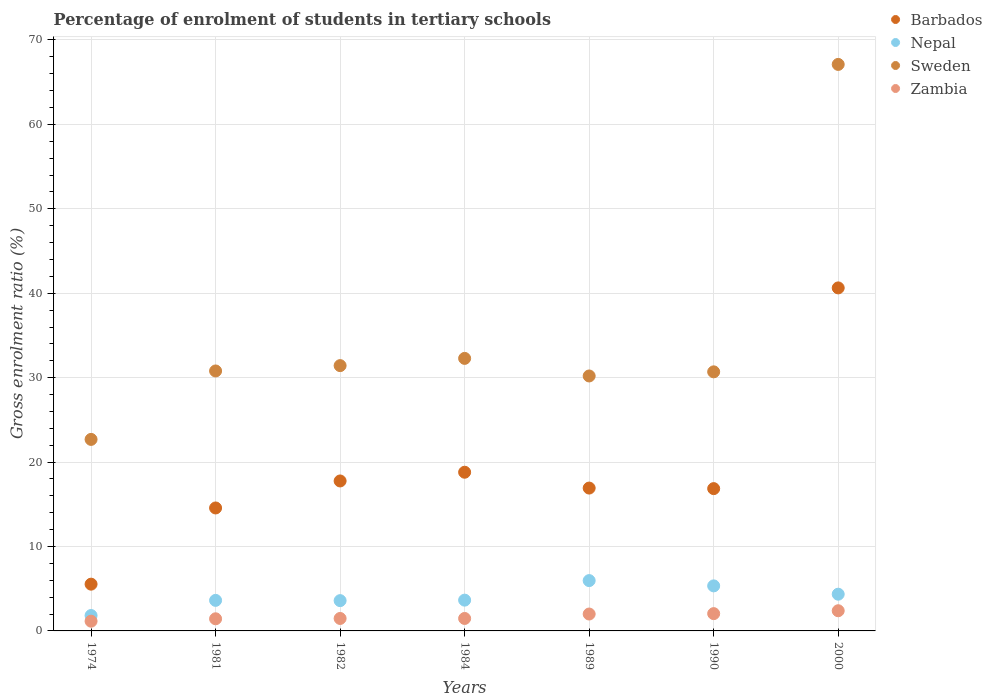What is the percentage of students enrolled in tertiary schools in Zambia in 2000?
Offer a terse response. 2.39. Across all years, what is the maximum percentage of students enrolled in tertiary schools in Barbados?
Offer a terse response. 40.63. Across all years, what is the minimum percentage of students enrolled in tertiary schools in Sweden?
Offer a very short reply. 22.69. In which year was the percentage of students enrolled in tertiary schools in Nepal minimum?
Give a very brief answer. 1974. What is the total percentage of students enrolled in tertiary schools in Barbados in the graph?
Offer a terse response. 131.07. What is the difference between the percentage of students enrolled in tertiary schools in Nepal in 1982 and that in 1990?
Offer a terse response. -1.75. What is the difference between the percentage of students enrolled in tertiary schools in Sweden in 1989 and the percentage of students enrolled in tertiary schools in Zambia in 2000?
Your answer should be very brief. 27.81. What is the average percentage of students enrolled in tertiary schools in Sweden per year?
Your answer should be very brief. 35.03. In the year 2000, what is the difference between the percentage of students enrolled in tertiary schools in Zambia and percentage of students enrolled in tertiary schools in Nepal?
Offer a terse response. -1.96. What is the ratio of the percentage of students enrolled in tertiary schools in Zambia in 1989 to that in 1990?
Your answer should be compact. 0.98. Is the percentage of students enrolled in tertiary schools in Nepal in 1981 less than that in 1989?
Your answer should be compact. Yes. Is the difference between the percentage of students enrolled in tertiary schools in Zambia in 1982 and 2000 greater than the difference between the percentage of students enrolled in tertiary schools in Nepal in 1982 and 2000?
Your response must be concise. No. What is the difference between the highest and the second highest percentage of students enrolled in tertiary schools in Sweden?
Provide a short and direct response. 34.82. What is the difference between the highest and the lowest percentage of students enrolled in tertiary schools in Nepal?
Keep it short and to the point. 4.14. Is the sum of the percentage of students enrolled in tertiary schools in Sweden in 1974 and 1982 greater than the maximum percentage of students enrolled in tertiary schools in Nepal across all years?
Provide a short and direct response. Yes. Is it the case that in every year, the sum of the percentage of students enrolled in tertiary schools in Zambia and percentage of students enrolled in tertiary schools in Sweden  is greater than the sum of percentage of students enrolled in tertiary schools in Nepal and percentage of students enrolled in tertiary schools in Barbados?
Your answer should be compact. Yes. Does the percentage of students enrolled in tertiary schools in Nepal monotonically increase over the years?
Your answer should be compact. No. How many dotlines are there?
Offer a terse response. 4. What is the difference between two consecutive major ticks on the Y-axis?
Your response must be concise. 10. Does the graph contain any zero values?
Ensure brevity in your answer.  No. Does the graph contain grids?
Offer a terse response. Yes. Where does the legend appear in the graph?
Your response must be concise. Top right. How many legend labels are there?
Make the answer very short. 4. What is the title of the graph?
Your answer should be compact. Percentage of enrolment of students in tertiary schools. Does "Lower middle income" appear as one of the legend labels in the graph?
Give a very brief answer. No. What is the label or title of the X-axis?
Your response must be concise. Years. What is the Gross enrolment ratio (%) of Barbados in 1974?
Provide a succinct answer. 5.54. What is the Gross enrolment ratio (%) of Nepal in 1974?
Your response must be concise. 1.82. What is the Gross enrolment ratio (%) in Sweden in 1974?
Offer a terse response. 22.69. What is the Gross enrolment ratio (%) of Zambia in 1974?
Your answer should be compact. 1.15. What is the Gross enrolment ratio (%) in Barbados in 1981?
Your answer should be very brief. 14.56. What is the Gross enrolment ratio (%) in Nepal in 1981?
Give a very brief answer. 3.62. What is the Gross enrolment ratio (%) in Sweden in 1981?
Your answer should be very brief. 30.79. What is the Gross enrolment ratio (%) of Zambia in 1981?
Offer a terse response. 1.44. What is the Gross enrolment ratio (%) in Barbados in 1982?
Your response must be concise. 17.76. What is the Gross enrolment ratio (%) of Nepal in 1982?
Keep it short and to the point. 3.59. What is the Gross enrolment ratio (%) in Sweden in 1982?
Your answer should be compact. 31.43. What is the Gross enrolment ratio (%) of Zambia in 1982?
Your answer should be very brief. 1.48. What is the Gross enrolment ratio (%) of Barbados in 1984?
Offer a terse response. 18.8. What is the Gross enrolment ratio (%) of Nepal in 1984?
Give a very brief answer. 3.65. What is the Gross enrolment ratio (%) in Sweden in 1984?
Your answer should be very brief. 32.28. What is the Gross enrolment ratio (%) in Zambia in 1984?
Provide a short and direct response. 1.48. What is the Gross enrolment ratio (%) of Barbados in 1989?
Provide a short and direct response. 16.92. What is the Gross enrolment ratio (%) in Nepal in 1989?
Provide a succinct answer. 5.96. What is the Gross enrolment ratio (%) in Sweden in 1989?
Provide a succinct answer. 30.2. What is the Gross enrolment ratio (%) in Zambia in 1989?
Make the answer very short. 2. What is the Gross enrolment ratio (%) in Barbados in 1990?
Your answer should be very brief. 16.86. What is the Gross enrolment ratio (%) in Nepal in 1990?
Ensure brevity in your answer.  5.34. What is the Gross enrolment ratio (%) of Sweden in 1990?
Offer a terse response. 30.69. What is the Gross enrolment ratio (%) in Zambia in 1990?
Offer a terse response. 2.05. What is the Gross enrolment ratio (%) of Barbados in 2000?
Keep it short and to the point. 40.63. What is the Gross enrolment ratio (%) in Nepal in 2000?
Give a very brief answer. 4.35. What is the Gross enrolment ratio (%) in Sweden in 2000?
Make the answer very short. 67.11. What is the Gross enrolment ratio (%) in Zambia in 2000?
Ensure brevity in your answer.  2.39. Across all years, what is the maximum Gross enrolment ratio (%) in Barbados?
Ensure brevity in your answer.  40.63. Across all years, what is the maximum Gross enrolment ratio (%) of Nepal?
Your answer should be compact. 5.96. Across all years, what is the maximum Gross enrolment ratio (%) in Sweden?
Offer a very short reply. 67.11. Across all years, what is the maximum Gross enrolment ratio (%) of Zambia?
Give a very brief answer. 2.39. Across all years, what is the minimum Gross enrolment ratio (%) of Barbados?
Your response must be concise. 5.54. Across all years, what is the minimum Gross enrolment ratio (%) in Nepal?
Give a very brief answer. 1.82. Across all years, what is the minimum Gross enrolment ratio (%) of Sweden?
Provide a succinct answer. 22.69. Across all years, what is the minimum Gross enrolment ratio (%) in Zambia?
Provide a short and direct response. 1.15. What is the total Gross enrolment ratio (%) in Barbados in the graph?
Offer a very short reply. 131.07. What is the total Gross enrolment ratio (%) in Nepal in the graph?
Offer a very short reply. 28.32. What is the total Gross enrolment ratio (%) of Sweden in the graph?
Provide a short and direct response. 245.19. What is the total Gross enrolment ratio (%) of Zambia in the graph?
Offer a terse response. 11.98. What is the difference between the Gross enrolment ratio (%) of Barbados in 1974 and that in 1981?
Provide a succinct answer. -9.03. What is the difference between the Gross enrolment ratio (%) in Nepal in 1974 and that in 1981?
Offer a very short reply. -1.79. What is the difference between the Gross enrolment ratio (%) of Sweden in 1974 and that in 1981?
Ensure brevity in your answer.  -8.11. What is the difference between the Gross enrolment ratio (%) of Zambia in 1974 and that in 1981?
Give a very brief answer. -0.28. What is the difference between the Gross enrolment ratio (%) in Barbados in 1974 and that in 1982?
Provide a succinct answer. -12.22. What is the difference between the Gross enrolment ratio (%) of Nepal in 1974 and that in 1982?
Make the answer very short. -1.76. What is the difference between the Gross enrolment ratio (%) in Sweden in 1974 and that in 1982?
Keep it short and to the point. -8.74. What is the difference between the Gross enrolment ratio (%) of Zambia in 1974 and that in 1982?
Ensure brevity in your answer.  -0.32. What is the difference between the Gross enrolment ratio (%) of Barbados in 1974 and that in 1984?
Offer a very short reply. -13.26. What is the difference between the Gross enrolment ratio (%) in Nepal in 1974 and that in 1984?
Provide a short and direct response. -1.82. What is the difference between the Gross enrolment ratio (%) in Sweden in 1974 and that in 1984?
Provide a succinct answer. -9.6. What is the difference between the Gross enrolment ratio (%) in Zambia in 1974 and that in 1984?
Your answer should be compact. -0.32. What is the difference between the Gross enrolment ratio (%) of Barbados in 1974 and that in 1989?
Your answer should be compact. -11.38. What is the difference between the Gross enrolment ratio (%) of Nepal in 1974 and that in 1989?
Ensure brevity in your answer.  -4.14. What is the difference between the Gross enrolment ratio (%) in Sweden in 1974 and that in 1989?
Provide a succinct answer. -7.51. What is the difference between the Gross enrolment ratio (%) in Zambia in 1974 and that in 1989?
Offer a terse response. -0.85. What is the difference between the Gross enrolment ratio (%) of Barbados in 1974 and that in 1990?
Give a very brief answer. -11.32. What is the difference between the Gross enrolment ratio (%) of Nepal in 1974 and that in 1990?
Offer a very short reply. -3.51. What is the difference between the Gross enrolment ratio (%) in Sweden in 1974 and that in 1990?
Keep it short and to the point. -8. What is the difference between the Gross enrolment ratio (%) in Zambia in 1974 and that in 1990?
Your answer should be compact. -0.9. What is the difference between the Gross enrolment ratio (%) in Barbados in 1974 and that in 2000?
Offer a terse response. -35.09. What is the difference between the Gross enrolment ratio (%) of Nepal in 1974 and that in 2000?
Offer a very short reply. -2.53. What is the difference between the Gross enrolment ratio (%) of Sweden in 1974 and that in 2000?
Provide a succinct answer. -44.42. What is the difference between the Gross enrolment ratio (%) in Zambia in 1974 and that in 2000?
Your response must be concise. -1.24. What is the difference between the Gross enrolment ratio (%) in Barbados in 1981 and that in 1982?
Offer a terse response. -3.2. What is the difference between the Gross enrolment ratio (%) in Nepal in 1981 and that in 1982?
Your answer should be compact. 0.03. What is the difference between the Gross enrolment ratio (%) in Sweden in 1981 and that in 1982?
Your answer should be compact. -0.63. What is the difference between the Gross enrolment ratio (%) of Zambia in 1981 and that in 1982?
Provide a short and direct response. -0.04. What is the difference between the Gross enrolment ratio (%) in Barbados in 1981 and that in 1984?
Provide a short and direct response. -4.23. What is the difference between the Gross enrolment ratio (%) in Nepal in 1981 and that in 1984?
Make the answer very short. -0.03. What is the difference between the Gross enrolment ratio (%) of Sweden in 1981 and that in 1984?
Offer a very short reply. -1.49. What is the difference between the Gross enrolment ratio (%) in Zambia in 1981 and that in 1984?
Your answer should be very brief. -0.04. What is the difference between the Gross enrolment ratio (%) in Barbados in 1981 and that in 1989?
Offer a very short reply. -2.36. What is the difference between the Gross enrolment ratio (%) in Nepal in 1981 and that in 1989?
Offer a very short reply. -2.34. What is the difference between the Gross enrolment ratio (%) in Sweden in 1981 and that in 1989?
Provide a short and direct response. 0.59. What is the difference between the Gross enrolment ratio (%) in Zambia in 1981 and that in 1989?
Your answer should be very brief. -0.56. What is the difference between the Gross enrolment ratio (%) in Barbados in 1981 and that in 1990?
Provide a succinct answer. -2.29. What is the difference between the Gross enrolment ratio (%) of Nepal in 1981 and that in 1990?
Make the answer very short. -1.72. What is the difference between the Gross enrolment ratio (%) of Sweden in 1981 and that in 1990?
Your answer should be compact. 0.1. What is the difference between the Gross enrolment ratio (%) of Zambia in 1981 and that in 1990?
Ensure brevity in your answer.  -0.61. What is the difference between the Gross enrolment ratio (%) in Barbados in 1981 and that in 2000?
Provide a short and direct response. -26.07. What is the difference between the Gross enrolment ratio (%) of Nepal in 1981 and that in 2000?
Provide a succinct answer. -0.73. What is the difference between the Gross enrolment ratio (%) of Sweden in 1981 and that in 2000?
Provide a short and direct response. -36.31. What is the difference between the Gross enrolment ratio (%) in Zambia in 1981 and that in 2000?
Provide a short and direct response. -0.95. What is the difference between the Gross enrolment ratio (%) of Barbados in 1982 and that in 1984?
Offer a very short reply. -1.03. What is the difference between the Gross enrolment ratio (%) in Nepal in 1982 and that in 1984?
Give a very brief answer. -0.06. What is the difference between the Gross enrolment ratio (%) of Sweden in 1982 and that in 1984?
Offer a terse response. -0.86. What is the difference between the Gross enrolment ratio (%) in Zambia in 1982 and that in 1984?
Your response must be concise. -0. What is the difference between the Gross enrolment ratio (%) of Barbados in 1982 and that in 1989?
Offer a terse response. 0.84. What is the difference between the Gross enrolment ratio (%) of Nepal in 1982 and that in 1989?
Offer a very short reply. -2.37. What is the difference between the Gross enrolment ratio (%) in Sweden in 1982 and that in 1989?
Your answer should be compact. 1.23. What is the difference between the Gross enrolment ratio (%) of Zambia in 1982 and that in 1989?
Give a very brief answer. -0.53. What is the difference between the Gross enrolment ratio (%) of Barbados in 1982 and that in 1990?
Your answer should be very brief. 0.91. What is the difference between the Gross enrolment ratio (%) of Nepal in 1982 and that in 1990?
Provide a succinct answer. -1.75. What is the difference between the Gross enrolment ratio (%) in Sweden in 1982 and that in 1990?
Provide a short and direct response. 0.74. What is the difference between the Gross enrolment ratio (%) in Zambia in 1982 and that in 1990?
Ensure brevity in your answer.  -0.57. What is the difference between the Gross enrolment ratio (%) in Barbados in 1982 and that in 2000?
Offer a very short reply. -22.87. What is the difference between the Gross enrolment ratio (%) in Nepal in 1982 and that in 2000?
Keep it short and to the point. -0.76. What is the difference between the Gross enrolment ratio (%) of Sweden in 1982 and that in 2000?
Offer a terse response. -35.68. What is the difference between the Gross enrolment ratio (%) in Zambia in 1982 and that in 2000?
Provide a short and direct response. -0.92. What is the difference between the Gross enrolment ratio (%) in Barbados in 1984 and that in 1989?
Your answer should be compact. 1.88. What is the difference between the Gross enrolment ratio (%) in Nepal in 1984 and that in 1989?
Your answer should be very brief. -2.31. What is the difference between the Gross enrolment ratio (%) of Sweden in 1984 and that in 1989?
Your response must be concise. 2.08. What is the difference between the Gross enrolment ratio (%) of Zambia in 1984 and that in 1989?
Provide a succinct answer. -0.53. What is the difference between the Gross enrolment ratio (%) in Barbados in 1984 and that in 1990?
Provide a short and direct response. 1.94. What is the difference between the Gross enrolment ratio (%) in Nepal in 1984 and that in 1990?
Keep it short and to the point. -1.69. What is the difference between the Gross enrolment ratio (%) of Sweden in 1984 and that in 1990?
Your response must be concise. 1.59. What is the difference between the Gross enrolment ratio (%) in Zambia in 1984 and that in 1990?
Provide a succinct answer. -0.57. What is the difference between the Gross enrolment ratio (%) in Barbados in 1984 and that in 2000?
Offer a very short reply. -21.83. What is the difference between the Gross enrolment ratio (%) in Nepal in 1984 and that in 2000?
Give a very brief answer. -0.7. What is the difference between the Gross enrolment ratio (%) in Sweden in 1984 and that in 2000?
Your response must be concise. -34.82. What is the difference between the Gross enrolment ratio (%) of Zambia in 1984 and that in 2000?
Your answer should be very brief. -0.91. What is the difference between the Gross enrolment ratio (%) in Barbados in 1989 and that in 1990?
Offer a very short reply. 0.07. What is the difference between the Gross enrolment ratio (%) of Nepal in 1989 and that in 1990?
Your answer should be compact. 0.63. What is the difference between the Gross enrolment ratio (%) of Sweden in 1989 and that in 1990?
Give a very brief answer. -0.49. What is the difference between the Gross enrolment ratio (%) in Zambia in 1989 and that in 1990?
Offer a terse response. -0.05. What is the difference between the Gross enrolment ratio (%) of Barbados in 1989 and that in 2000?
Your answer should be very brief. -23.71. What is the difference between the Gross enrolment ratio (%) in Nepal in 1989 and that in 2000?
Give a very brief answer. 1.61. What is the difference between the Gross enrolment ratio (%) of Sweden in 1989 and that in 2000?
Make the answer very short. -36.91. What is the difference between the Gross enrolment ratio (%) in Zambia in 1989 and that in 2000?
Ensure brevity in your answer.  -0.39. What is the difference between the Gross enrolment ratio (%) in Barbados in 1990 and that in 2000?
Ensure brevity in your answer.  -23.78. What is the difference between the Gross enrolment ratio (%) of Nepal in 1990 and that in 2000?
Ensure brevity in your answer.  0.98. What is the difference between the Gross enrolment ratio (%) in Sweden in 1990 and that in 2000?
Your answer should be very brief. -36.42. What is the difference between the Gross enrolment ratio (%) of Zambia in 1990 and that in 2000?
Offer a terse response. -0.34. What is the difference between the Gross enrolment ratio (%) in Barbados in 1974 and the Gross enrolment ratio (%) in Nepal in 1981?
Give a very brief answer. 1.92. What is the difference between the Gross enrolment ratio (%) in Barbados in 1974 and the Gross enrolment ratio (%) in Sweden in 1981?
Ensure brevity in your answer.  -25.25. What is the difference between the Gross enrolment ratio (%) of Barbados in 1974 and the Gross enrolment ratio (%) of Zambia in 1981?
Your answer should be very brief. 4.1. What is the difference between the Gross enrolment ratio (%) in Nepal in 1974 and the Gross enrolment ratio (%) in Sweden in 1981?
Ensure brevity in your answer.  -28.97. What is the difference between the Gross enrolment ratio (%) in Nepal in 1974 and the Gross enrolment ratio (%) in Zambia in 1981?
Your answer should be very brief. 0.39. What is the difference between the Gross enrolment ratio (%) of Sweden in 1974 and the Gross enrolment ratio (%) of Zambia in 1981?
Ensure brevity in your answer.  21.25. What is the difference between the Gross enrolment ratio (%) in Barbados in 1974 and the Gross enrolment ratio (%) in Nepal in 1982?
Ensure brevity in your answer.  1.95. What is the difference between the Gross enrolment ratio (%) of Barbados in 1974 and the Gross enrolment ratio (%) of Sweden in 1982?
Make the answer very short. -25.89. What is the difference between the Gross enrolment ratio (%) of Barbados in 1974 and the Gross enrolment ratio (%) of Zambia in 1982?
Ensure brevity in your answer.  4.06. What is the difference between the Gross enrolment ratio (%) in Nepal in 1974 and the Gross enrolment ratio (%) in Sweden in 1982?
Make the answer very short. -29.6. What is the difference between the Gross enrolment ratio (%) in Nepal in 1974 and the Gross enrolment ratio (%) in Zambia in 1982?
Provide a succinct answer. 0.35. What is the difference between the Gross enrolment ratio (%) in Sweden in 1974 and the Gross enrolment ratio (%) in Zambia in 1982?
Offer a terse response. 21.21. What is the difference between the Gross enrolment ratio (%) in Barbados in 1974 and the Gross enrolment ratio (%) in Nepal in 1984?
Give a very brief answer. 1.89. What is the difference between the Gross enrolment ratio (%) of Barbados in 1974 and the Gross enrolment ratio (%) of Sweden in 1984?
Provide a short and direct response. -26.74. What is the difference between the Gross enrolment ratio (%) of Barbados in 1974 and the Gross enrolment ratio (%) of Zambia in 1984?
Your answer should be very brief. 4.06. What is the difference between the Gross enrolment ratio (%) in Nepal in 1974 and the Gross enrolment ratio (%) in Sweden in 1984?
Make the answer very short. -30.46. What is the difference between the Gross enrolment ratio (%) of Nepal in 1974 and the Gross enrolment ratio (%) of Zambia in 1984?
Provide a succinct answer. 0.35. What is the difference between the Gross enrolment ratio (%) in Sweden in 1974 and the Gross enrolment ratio (%) in Zambia in 1984?
Offer a terse response. 21.21. What is the difference between the Gross enrolment ratio (%) in Barbados in 1974 and the Gross enrolment ratio (%) in Nepal in 1989?
Make the answer very short. -0.42. What is the difference between the Gross enrolment ratio (%) in Barbados in 1974 and the Gross enrolment ratio (%) in Sweden in 1989?
Keep it short and to the point. -24.66. What is the difference between the Gross enrolment ratio (%) of Barbados in 1974 and the Gross enrolment ratio (%) of Zambia in 1989?
Give a very brief answer. 3.54. What is the difference between the Gross enrolment ratio (%) of Nepal in 1974 and the Gross enrolment ratio (%) of Sweden in 1989?
Provide a short and direct response. -28.38. What is the difference between the Gross enrolment ratio (%) of Nepal in 1974 and the Gross enrolment ratio (%) of Zambia in 1989?
Keep it short and to the point. -0.18. What is the difference between the Gross enrolment ratio (%) in Sweden in 1974 and the Gross enrolment ratio (%) in Zambia in 1989?
Make the answer very short. 20.69. What is the difference between the Gross enrolment ratio (%) of Barbados in 1974 and the Gross enrolment ratio (%) of Nepal in 1990?
Your response must be concise. 0.2. What is the difference between the Gross enrolment ratio (%) in Barbados in 1974 and the Gross enrolment ratio (%) in Sweden in 1990?
Your answer should be compact. -25.15. What is the difference between the Gross enrolment ratio (%) of Barbados in 1974 and the Gross enrolment ratio (%) of Zambia in 1990?
Keep it short and to the point. 3.49. What is the difference between the Gross enrolment ratio (%) of Nepal in 1974 and the Gross enrolment ratio (%) of Sweden in 1990?
Make the answer very short. -28.87. What is the difference between the Gross enrolment ratio (%) of Nepal in 1974 and the Gross enrolment ratio (%) of Zambia in 1990?
Make the answer very short. -0.22. What is the difference between the Gross enrolment ratio (%) in Sweden in 1974 and the Gross enrolment ratio (%) in Zambia in 1990?
Offer a terse response. 20.64. What is the difference between the Gross enrolment ratio (%) in Barbados in 1974 and the Gross enrolment ratio (%) in Nepal in 2000?
Give a very brief answer. 1.19. What is the difference between the Gross enrolment ratio (%) of Barbados in 1974 and the Gross enrolment ratio (%) of Sweden in 2000?
Your answer should be very brief. -61.57. What is the difference between the Gross enrolment ratio (%) in Barbados in 1974 and the Gross enrolment ratio (%) in Zambia in 2000?
Provide a succinct answer. 3.15. What is the difference between the Gross enrolment ratio (%) of Nepal in 1974 and the Gross enrolment ratio (%) of Sweden in 2000?
Your answer should be very brief. -65.28. What is the difference between the Gross enrolment ratio (%) of Nepal in 1974 and the Gross enrolment ratio (%) of Zambia in 2000?
Your answer should be very brief. -0.57. What is the difference between the Gross enrolment ratio (%) in Sweden in 1974 and the Gross enrolment ratio (%) in Zambia in 2000?
Make the answer very short. 20.3. What is the difference between the Gross enrolment ratio (%) of Barbados in 1981 and the Gross enrolment ratio (%) of Nepal in 1982?
Ensure brevity in your answer.  10.98. What is the difference between the Gross enrolment ratio (%) in Barbados in 1981 and the Gross enrolment ratio (%) in Sweden in 1982?
Your response must be concise. -16.86. What is the difference between the Gross enrolment ratio (%) in Barbados in 1981 and the Gross enrolment ratio (%) in Zambia in 1982?
Make the answer very short. 13.09. What is the difference between the Gross enrolment ratio (%) in Nepal in 1981 and the Gross enrolment ratio (%) in Sweden in 1982?
Give a very brief answer. -27.81. What is the difference between the Gross enrolment ratio (%) in Nepal in 1981 and the Gross enrolment ratio (%) in Zambia in 1982?
Make the answer very short. 2.14. What is the difference between the Gross enrolment ratio (%) of Sweden in 1981 and the Gross enrolment ratio (%) of Zambia in 1982?
Make the answer very short. 29.32. What is the difference between the Gross enrolment ratio (%) of Barbados in 1981 and the Gross enrolment ratio (%) of Nepal in 1984?
Make the answer very short. 10.92. What is the difference between the Gross enrolment ratio (%) of Barbados in 1981 and the Gross enrolment ratio (%) of Sweden in 1984?
Keep it short and to the point. -17.72. What is the difference between the Gross enrolment ratio (%) in Barbados in 1981 and the Gross enrolment ratio (%) in Zambia in 1984?
Your answer should be very brief. 13.09. What is the difference between the Gross enrolment ratio (%) in Nepal in 1981 and the Gross enrolment ratio (%) in Sweden in 1984?
Your answer should be compact. -28.66. What is the difference between the Gross enrolment ratio (%) of Nepal in 1981 and the Gross enrolment ratio (%) of Zambia in 1984?
Make the answer very short. 2.14. What is the difference between the Gross enrolment ratio (%) of Sweden in 1981 and the Gross enrolment ratio (%) of Zambia in 1984?
Give a very brief answer. 29.32. What is the difference between the Gross enrolment ratio (%) of Barbados in 1981 and the Gross enrolment ratio (%) of Nepal in 1989?
Your answer should be compact. 8.6. What is the difference between the Gross enrolment ratio (%) of Barbados in 1981 and the Gross enrolment ratio (%) of Sweden in 1989?
Make the answer very short. -15.64. What is the difference between the Gross enrolment ratio (%) in Barbados in 1981 and the Gross enrolment ratio (%) in Zambia in 1989?
Your response must be concise. 12.56. What is the difference between the Gross enrolment ratio (%) of Nepal in 1981 and the Gross enrolment ratio (%) of Sweden in 1989?
Ensure brevity in your answer.  -26.58. What is the difference between the Gross enrolment ratio (%) of Nepal in 1981 and the Gross enrolment ratio (%) of Zambia in 1989?
Keep it short and to the point. 1.62. What is the difference between the Gross enrolment ratio (%) in Sweden in 1981 and the Gross enrolment ratio (%) in Zambia in 1989?
Ensure brevity in your answer.  28.79. What is the difference between the Gross enrolment ratio (%) of Barbados in 1981 and the Gross enrolment ratio (%) of Nepal in 1990?
Your answer should be compact. 9.23. What is the difference between the Gross enrolment ratio (%) in Barbados in 1981 and the Gross enrolment ratio (%) in Sweden in 1990?
Give a very brief answer. -16.12. What is the difference between the Gross enrolment ratio (%) of Barbados in 1981 and the Gross enrolment ratio (%) of Zambia in 1990?
Your answer should be compact. 12.52. What is the difference between the Gross enrolment ratio (%) of Nepal in 1981 and the Gross enrolment ratio (%) of Sweden in 1990?
Your response must be concise. -27.07. What is the difference between the Gross enrolment ratio (%) of Nepal in 1981 and the Gross enrolment ratio (%) of Zambia in 1990?
Offer a terse response. 1.57. What is the difference between the Gross enrolment ratio (%) of Sweden in 1981 and the Gross enrolment ratio (%) of Zambia in 1990?
Offer a very short reply. 28.75. What is the difference between the Gross enrolment ratio (%) in Barbados in 1981 and the Gross enrolment ratio (%) in Nepal in 2000?
Provide a short and direct response. 10.21. What is the difference between the Gross enrolment ratio (%) in Barbados in 1981 and the Gross enrolment ratio (%) in Sweden in 2000?
Provide a short and direct response. -52.54. What is the difference between the Gross enrolment ratio (%) of Barbados in 1981 and the Gross enrolment ratio (%) of Zambia in 2000?
Give a very brief answer. 12.17. What is the difference between the Gross enrolment ratio (%) of Nepal in 1981 and the Gross enrolment ratio (%) of Sweden in 2000?
Give a very brief answer. -63.49. What is the difference between the Gross enrolment ratio (%) in Nepal in 1981 and the Gross enrolment ratio (%) in Zambia in 2000?
Provide a succinct answer. 1.23. What is the difference between the Gross enrolment ratio (%) of Sweden in 1981 and the Gross enrolment ratio (%) of Zambia in 2000?
Your response must be concise. 28.4. What is the difference between the Gross enrolment ratio (%) of Barbados in 1982 and the Gross enrolment ratio (%) of Nepal in 1984?
Provide a short and direct response. 14.12. What is the difference between the Gross enrolment ratio (%) of Barbados in 1982 and the Gross enrolment ratio (%) of Sweden in 1984?
Give a very brief answer. -14.52. What is the difference between the Gross enrolment ratio (%) of Barbados in 1982 and the Gross enrolment ratio (%) of Zambia in 1984?
Offer a very short reply. 16.29. What is the difference between the Gross enrolment ratio (%) in Nepal in 1982 and the Gross enrolment ratio (%) in Sweden in 1984?
Offer a terse response. -28.69. What is the difference between the Gross enrolment ratio (%) in Nepal in 1982 and the Gross enrolment ratio (%) in Zambia in 1984?
Ensure brevity in your answer.  2.11. What is the difference between the Gross enrolment ratio (%) in Sweden in 1982 and the Gross enrolment ratio (%) in Zambia in 1984?
Your answer should be very brief. 29.95. What is the difference between the Gross enrolment ratio (%) of Barbados in 1982 and the Gross enrolment ratio (%) of Nepal in 1989?
Make the answer very short. 11.8. What is the difference between the Gross enrolment ratio (%) in Barbados in 1982 and the Gross enrolment ratio (%) in Sweden in 1989?
Offer a terse response. -12.44. What is the difference between the Gross enrolment ratio (%) of Barbados in 1982 and the Gross enrolment ratio (%) of Zambia in 1989?
Your answer should be very brief. 15.76. What is the difference between the Gross enrolment ratio (%) of Nepal in 1982 and the Gross enrolment ratio (%) of Sweden in 1989?
Ensure brevity in your answer.  -26.61. What is the difference between the Gross enrolment ratio (%) of Nepal in 1982 and the Gross enrolment ratio (%) of Zambia in 1989?
Ensure brevity in your answer.  1.59. What is the difference between the Gross enrolment ratio (%) in Sweden in 1982 and the Gross enrolment ratio (%) in Zambia in 1989?
Your answer should be compact. 29.43. What is the difference between the Gross enrolment ratio (%) of Barbados in 1982 and the Gross enrolment ratio (%) of Nepal in 1990?
Your response must be concise. 12.43. What is the difference between the Gross enrolment ratio (%) in Barbados in 1982 and the Gross enrolment ratio (%) in Sweden in 1990?
Make the answer very short. -12.93. What is the difference between the Gross enrolment ratio (%) of Barbados in 1982 and the Gross enrolment ratio (%) of Zambia in 1990?
Offer a very short reply. 15.72. What is the difference between the Gross enrolment ratio (%) of Nepal in 1982 and the Gross enrolment ratio (%) of Sweden in 1990?
Your response must be concise. -27.1. What is the difference between the Gross enrolment ratio (%) in Nepal in 1982 and the Gross enrolment ratio (%) in Zambia in 1990?
Offer a very short reply. 1.54. What is the difference between the Gross enrolment ratio (%) of Sweden in 1982 and the Gross enrolment ratio (%) of Zambia in 1990?
Offer a very short reply. 29.38. What is the difference between the Gross enrolment ratio (%) of Barbados in 1982 and the Gross enrolment ratio (%) of Nepal in 2000?
Keep it short and to the point. 13.41. What is the difference between the Gross enrolment ratio (%) of Barbados in 1982 and the Gross enrolment ratio (%) of Sweden in 2000?
Provide a succinct answer. -49.34. What is the difference between the Gross enrolment ratio (%) in Barbados in 1982 and the Gross enrolment ratio (%) in Zambia in 2000?
Ensure brevity in your answer.  15.37. What is the difference between the Gross enrolment ratio (%) in Nepal in 1982 and the Gross enrolment ratio (%) in Sweden in 2000?
Your answer should be very brief. -63.52. What is the difference between the Gross enrolment ratio (%) of Nepal in 1982 and the Gross enrolment ratio (%) of Zambia in 2000?
Your response must be concise. 1.2. What is the difference between the Gross enrolment ratio (%) of Sweden in 1982 and the Gross enrolment ratio (%) of Zambia in 2000?
Make the answer very short. 29.04. What is the difference between the Gross enrolment ratio (%) of Barbados in 1984 and the Gross enrolment ratio (%) of Nepal in 1989?
Your answer should be very brief. 12.84. What is the difference between the Gross enrolment ratio (%) in Barbados in 1984 and the Gross enrolment ratio (%) in Sweden in 1989?
Your answer should be very brief. -11.4. What is the difference between the Gross enrolment ratio (%) in Barbados in 1984 and the Gross enrolment ratio (%) in Zambia in 1989?
Keep it short and to the point. 16.8. What is the difference between the Gross enrolment ratio (%) in Nepal in 1984 and the Gross enrolment ratio (%) in Sweden in 1989?
Give a very brief answer. -26.55. What is the difference between the Gross enrolment ratio (%) in Nepal in 1984 and the Gross enrolment ratio (%) in Zambia in 1989?
Offer a very short reply. 1.64. What is the difference between the Gross enrolment ratio (%) in Sweden in 1984 and the Gross enrolment ratio (%) in Zambia in 1989?
Make the answer very short. 30.28. What is the difference between the Gross enrolment ratio (%) of Barbados in 1984 and the Gross enrolment ratio (%) of Nepal in 1990?
Your answer should be very brief. 13.46. What is the difference between the Gross enrolment ratio (%) of Barbados in 1984 and the Gross enrolment ratio (%) of Sweden in 1990?
Your response must be concise. -11.89. What is the difference between the Gross enrolment ratio (%) of Barbados in 1984 and the Gross enrolment ratio (%) of Zambia in 1990?
Keep it short and to the point. 16.75. What is the difference between the Gross enrolment ratio (%) in Nepal in 1984 and the Gross enrolment ratio (%) in Sweden in 1990?
Ensure brevity in your answer.  -27.04. What is the difference between the Gross enrolment ratio (%) in Nepal in 1984 and the Gross enrolment ratio (%) in Zambia in 1990?
Your answer should be very brief. 1.6. What is the difference between the Gross enrolment ratio (%) of Sweden in 1984 and the Gross enrolment ratio (%) of Zambia in 1990?
Make the answer very short. 30.23. What is the difference between the Gross enrolment ratio (%) of Barbados in 1984 and the Gross enrolment ratio (%) of Nepal in 2000?
Provide a short and direct response. 14.45. What is the difference between the Gross enrolment ratio (%) of Barbados in 1984 and the Gross enrolment ratio (%) of Sweden in 2000?
Provide a succinct answer. -48.31. What is the difference between the Gross enrolment ratio (%) of Barbados in 1984 and the Gross enrolment ratio (%) of Zambia in 2000?
Your answer should be very brief. 16.41. What is the difference between the Gross enrolment ratio (%) in Nepal in 1984 and the Gross enrolment ratio (%) in Sweden in 2000?
Ensure brevity in your answer.  -63.46. What is the difference between the Gross enrolment ratio (%) in Nepal in 1984 and the Gross enrolment ratio (%) in Zambia in 2000?
Ensure brevity in your answer.  1.26. What is the difference between the Gross enrolment ratio (%) of Sweden in 1984 and the Gross enrolment ratio (%) of Zambia in 2000?
Keep it short and to the point. 29.89. What is the difference between the Gross enrolment ratio (%) in Barbados in 1989 and the Gross enrolment ratio (%) in Nepal in 1990?
Your response must be concise. 11.59. What is the difference between the Gross enrolment ratio (%) of Barbados in 1989 and the Gross enrolment ratio (%) of Sweden in 1990?
Keep it short and to the point. -13.77. What is the difference between the Gross enrolment ratio (%) in Barbados in 1989 and the Gross enrolment ratio (%) in Zambia in 1990?
Your answer should be very brief. 14.87. What is the difference between the Gross enrolment ratio (%) of Nepal in 1989 and the Gross enrolment ratio (%) of Sweden in 1990?
Ensure brevity in your answer.  -24.73. What is the difference between the Gross enrolment ratio (%) in Nepal in 1989 and the Gross enrolment ratio (%) in Zambia in 1990?
Provide a succinct answer. 3.91. What is the difference between the Gross enrolment ratio (%) in Sweden in 1989 and the Gross enrolment ratio (%) in Zambia in 1990?
Your response must be concise. 28.15. What is the difference between the Gross enrolment ratio (%) of Barbados in 1989 and the Gross enrolment ratio (%) of Nepal in 2000?
Your response must be concise. 12.57. What is the difference between the Gross enrolment ratio (%) of Barbados in 1989 and the Gross enrolment ratio (%) of Sweden in 2000?
Make the answer very short. -50.18. What is the difference between the Gross enrolment ratio (%) of Barbados in 1989 and the Gross enrolment ratio (%) of Zambia in 2000?
Your response must be concise. 14.53. What is the difference between the Gross enrolment ratio (%) of Nepal in 1989 and the Gross enrolment ratio (%) of Sweden in 2000?
Your answer should be very brief. -61.14. What is the difference between the Gross enrolment ratio (%) of Nepal in 1989 and the Gross enrolment ratio (%) of Zambia in 2000?
Your answer should be very brief. 3.57. What is the difference between the Gross enrolment ratio (%) in Sweden in 1989 and the Gross enrolment ratio (%) in Zambia in 2000?
Offer a terse response. 27.81. What is the difference between the Gross enrolment ratio (%) of Barbados in 1990 and the Gross enrolment ratio (%) of Nepal in 2000?
Your answer should be very brief. 12.51. What is the difference between the Gross enrolment ratio (%) in Barbados in 1990 and the Gross enrolment ratio (%) in Sweden in 2000?
Provide a succinct answer. -50.25. What is the difference between the Gross enrolment ratio (%) of Barbados in 1990 and the Gross enrolment ratio (%) of Zambia in 2000?
Provide a succinct answer. 14.47. What is the difference between the Gross enrolment ratio (%) in Nepal in 1990 and the Gross enrolment ratio (%) in Sweden in 2000?
Your answer should be very brief. -61.77. What is the difference between the Gross enrolment ratio (%) of Nepal in 1990 and the Gross enrolment ratio (%) of Zambia in 2000?
Offer a very short reply. 2.94. What is the difference between the Gross enrolment ratio (%) in Sweden in 1990 and the Gross enrolment ratio (%) in Zambia in 2000?
Your response must be concise. 28.3. What is the average Gross enrolment ratio (%) of Barbados per year?
Give a very brief answer. 18.72. What is the average Gross enrolment ratio (%) in Nepal per year?
Offer a terse response. 4.05. What is the average Gross enrolment ratio (%) in Sweden per year?
Keep it short and to the point. 35.03. What is the average Gross enrolment ratio (%) of Zambia per year?
Give a very brief answer. 1.71. In the year 1974, what is the difference between the Gross enrolment ratio (%) in Barbados and Gross enrolment ratio (%) in Nepal?
Your answer should be very brief. 3.71. In the year 1974, what is the difference between the Gross enrolment ratio (%) of Barbados and Gross enrolment ratio (%) of Sweden?
Your answer should be compact. -17.15. In the year 1974, what is the difference between the Gross enrolment ratio (%) of Barbados and Gross enrolment ratio (%) of Zambia?
Offer a terse response. 4.39. In the year 1974, what is the difference between the Gross enrolment ratio (%) in Nepal and Gross enrolment ratio (%) in Sweden?
Your answer should be compact. -20.86. In the year 1974, what is the difference between the Gross enrolment ratio (%) in Nepal and Gross enrolment ratio (%) in Zambia?
Offer a terse response. 0.67. In the year 1974, what is the difference between the Gross enrolment ratio (%) of Sweden and Gross enrolment ratio (%) of Zambia?
Give a very brief answer. 21.53. In the year 1981, what is the difference between the Gross enrolment ratio (%) in Barbados and Gross enrolment ratio (%) in Nepal?
Provide a short and direct response. 10.95. In the year 1981, what is the difference between the Gross enrolment ratio (%) of Barbados and Gross enrolment ratio (%) of Sweden?
Provide a short and direct response. -16.23. In the year 1981, what is the difference between the Gross enrolment ratio (%) of Barbados and Gross enrolment ratio (%) of Zambia?
Ensure brevity in your answer.  13.13. In the year 1981, what is the difference between the Gross enrolment ratio (%) in Nepal and Gross enrolment ratio (%) in Sweden?
Your answer should be very brief. -27.18. In the year 1981, what is the difference between the Gross enrolment ratio (%) in Nepal and Gross enrolment ratio (%) in Zambia?
Your response must be concise. 2.18. In the year 1981, what is the difference between the Gross enrolment ratio (%) in Sweden and Gross enrolment ratio (%) in Zambia?
Offer a very short reply. 29.36. In the year 1982, what is the difference between the Gross enrolment ratio (%) in Barbados and Gross enrolment ratio (%) in Nepal?
Offer a very short reply. 14.18. In the year 1982, what is the difference between the Gross enrolment ratio (%) in Barbados and Gross enrolment ratio (%) in Sweden?
Provide a short and direct response. -13.66. In the year 1982, what is the difference between the Gross enrolment ratio (%) of Barbados and Gross enrolment ratio (%) of Zambia?
Offer a terse response. 16.29. In the year 1982, what is the difference between the Gross enrolment ratio (%) in Nepal and Gross enrolment ratio (%) in Sweden?
Give a very brief answer. -27.84. In the year 1982, what is the difference between the Gross enrolment ratio (%) in Nepal and Gross enrolment ratio (%) in Zambia?
Give a very brief answer. 2.11. In the year 1982, what is the difference between the Gross enrolment ratio (%) of Sweden and Gross enrolment ratio (%) of Zambia?
Your answer should be very brief. 29.95. In the year 1984, what is the difference between the Gross enrolment ratio (%) in Barbados and Gross enrolment ratio (%) in Nepal?
Your answer should be very brief. 15.15. In the year 1984, what is the difference between the Gross enrolment ratio (%) in Barbados and Gross enrolment ratio (%) in Sweden?
Offer a terse response. -13.49. In the year 1984, what is the difference between the Gross enrolment ratio (%) in Barbados and Gross enrolment ratio (%) in Zambia?
Provide a short and direct response. 17.32. In the year 1984, what is the difference between the Gross enrolment ratio (%) of Nepal and Gross enrolment ratio (%) of Sweden?
Offer a terse response. -28.64. In the year 1984, what is the difference between the Gross enrolment ratio (%) of Nepal and Gross enrolment ratio (%) of Zambia?
Offer a terse response. 2.17. In the year 1984, what is the difference between the Gross enrolment ratio (%) in Sweden and Gross enrolment ratio (%) in Zambia?
Make the answer very short. 30.81. In the year 1989, what is the difference between the Gross enrolment ratio (%) of Barbados and Gross enrolment ratio (%) of Nepal?
Provide a succinct answer. 10.96. In the year 1989, what is the difference between the Gross enrolment ratio (%) in Barbados and Gross enrolment ratio (%) in Sweden?
Provide a short and direct response. -13.28. In the year 1989, what is the difference between the Gross enrolment ratio (%) of Barbados and Gross enrolment ratio (%) of Zambia?
Ensure brevity in your answer.  14.92. In the year 1989, what is the difference between the Gross enrolment ratio (%) in Nepal and Gross enrolment ratio (%) in Sweden?
Offer a very short reply. -24.24. In the year 1989, what is the difference between the Gross enrolment ratio (%) in Nepal and Gross enrolment ratio (%) in Zambia?
Your response must be concise. 3.96. In the year 1989, what is the difference between the Gross enrolment ratio (%) of Sweden and Gross enrolment ratio (%) of Zambia?
Make the answer very short. 28.2. In the year 1990, what is the difference between the Gross enrolment ratio (%) of Barbados and Gross enrolment ratio (%) of Nepal?
Make the answer very short. 11.52. In the year 1990, what is the difference between the Gross enrolment ratio (%) in Barbados and Gross enrolment ratio (%) in Sweden?
Offer a very short reply. -13.83. In the year 1990, what is the difference between the Gross enrolment ratio (%) of Barbados and Gross enrolment ratio (%) of Zambia?
Provide a succinct answer. 14.81. In the year 1990, what is the difference between the Gross enrolment ratio (%) in Nepal and Gross enrolment ratio (%) in Sweden?
Your answer should be compact. -25.35. In the year 1990, what is the difference between the Gross enrolment ratio (%) of Nepal and Gross enrolment ratio (%) of Zambia?
Your answer should be compact. 3.29. In the year 1990, what is the difference between the Gross enrolment ratio (%) of Sweden and Gross enrolment ratio (%) of Zambia?
Your answer should be compact. 28.64. In the year 2000, what is the difference between the Gross enrolment ratio (%) of Barbados and Gross enrolment ratio (%) of Nepal?
Your answer should be compact. 36.28. In the year 2000, what is the difference between the Gross enrolment ratio (%) of Barbados and Gross enrolment ratio (%) of Sweden?
Keep it short and to the point. -26.47. In the year 2000, what is the difference between the Gross enrolment ratio (%) in Barbados and Gross enrolment ratio (%) in Zambia?
Provide a short and direct response. 38.24. In the year 2000, what is the difference between the Gross enrolment ratio (%) of Nepal and Gross enrolment ratio (%) of Sweden?
Ensure brevity in your answer.  -62.76. In the year 2000, what is the difference between the Gross enrolment ratio (%) in Nepal and Gross enrolment ratio (%) in Zambia?
Your response must be concise. 1.96. In the year 2000, what is the difference between the Gross enrolment ratio (%) of Sweden and Gross enrolment ratio (%) of Zambia?
Ensure brevity in your answer.  64.72. What is the ratio of the Gross enrolment ratio (%) in Barbados in 1974 to that in 1981?
Provide a short and direct response. 0.38. What is the ratio of the Gross enrolment ratio (%) in Nepal in 1974 to that in 1981?
Your answer should be compact. 0.5. What is the ratio of the Gross enrolment ratio (%) of Sweden in 1974 to that in 1981?
Offer a terse response. 0.74. What is the ratio of the Gross enrolment ratio (%) of Zambia in 1974 to that in 1981?
Your response must be concise. 0.8. What is the ratio of the Gross enrolment ratio (%) of Barbados in 1974 to that in 1982?
Your answer should be compact. 0.31. What is the ratio of the Gross enrolment ratio (%) of Nepal in 1974 to that in 1982?
Your response must be concise. 0.51. What is the ratio of the Gross enrolment ratio (%) in Sweden in 1974 to that in 1982?
Offer a terse response. 0.72. What is the ratio of the Gross enrolment ratio (%) in Zambia in 1974 to that in 1982?
Your answer should be compact. 0.78. What is the ratio of the Gross enrolment ratio (%) in Barbados in 1974 to that in 1984?
Provide a succinct answer. 0.29. What is the ratio of the Gross enrolment ratio (%) in Nepal in 1974 to that in 1984?
Give a very brief answer. 0.5. What is the ratio of the Gross enrolment ratio (%) of Sweden in 1974 to that in 1984?
Provide a succinct answer. 0.7. What is the ratio of the Gross enrolment ratio (%) in Zambia in 1974 to that in 1984?
Ensure brevity in your answer.  0.78. What is the ratio of the Gross enrolment ratio (%) in Barbados in 1974 to that in 1989?
Offer a very short reply. 0.33. What is the ratio of the Gross enrolment ratio (%) of Nepal in 1974 to that in 1989?
Provide a short and direct response. 0.31. What is the ratio of the Gross enrolment ratio (%) in Sweden in 1974 to that in 1989?
Your answer should be compact. 0.75. What is the ratio of the Gross enrolment ratio (%) in Zambia in 1974 to that in 1989?
Your answer should be compact. 0.58. What is the ratio of the Gross enrolment ratio (%) in Barbados in 1974 to that in 1990?
Your answer should be very brief. 0.33. What is the ratio of the Gross enrolment ratio (%) in Nepal in 1974 to that in 1990?
Provide a short and direct response. 0.34. What is the ratio of the Gross enrolment ratio (%) of Sweden in 1974 to that in 1990?
Provide a succinct answer. 0.74. What is the ratio of the Gross enrolment ratio (%) of Zambia in 1974 to that in 1990?
Offer a very short reply. 0.56. What is the ratio of the Gross enrolment ratio (%) of Barbados in 1974 to that in 2000?
Offer a terse response. 0.14. What is the ratio of the Gross enrolment ratio (%) in Nepal in 1974 to that in 2000?
Offer a terse response. 0.42. What is the ratio of the Gross enrolment ratio (%) in Sweden in 1974 to that in 2000?
Offer a very short reply. 0.34. What is the ratio of the Gross enrolment ratio (%) of Zambia in 1974 to that in 2000?
Your answer should be very brief. 0.48. What is the ratio of the Gross enrolment ratio (%) of Barbados in 1981 to that in 1982?
Offer a very short reply. 0.82. What is the ratio of the Gross enrolment ratio (%) in Nepal in 1981 to that in 1982?
Your answer should be very brief. 1.01. What is the ratio of the Gross enrolment ratio (%) of Sweden in 1981 to that in 1982?
Your answer should be compact. 0.98. What is the ratio of the Gross enrolment ratio (%) of Zambia in 1981 to that in 1982?
Keep it short and to the point. 0.97. What is the ratio of the Gross enrolment ratio (%) in Barbados in 1981 to that in 1984?
Your response must be concise. 0.77. What is the ratio of the Gross enrolment ratio (%) of Nepal in 1981 to that in 1984?
Your answer should be very brief. 0.99. What is the ratio of the Gross enrolment ratio (%) of Sweden in 1981 to that in 1984?
Make the answer very short. 0.95. What is the ratio of the Gross enrolment ratio (%) of Zambia in 1981 to that in 1984?
Your response must be concise. 0.97. What is the ratio of the Gross enrolment ratio (%) of Barbados in 1981 to that in 1989?
Keep it short and to the point. 0.86. What is the ratio of the Gross enrolment ratio (%) in Nepal in 1981 to that in 1989?
Make the answer very short. 0.61. What is the ratio of the Gross enrolment ratio (%) in Sweden in 1981 to that in 1989?
Offer a very short reply. 1.02. What is the ratio of the Gross enrolment ratio (%) of Zambia in 1981 to that in 1989?
Make the answer very short. 0.72. What is the ratio of the Gross enrolment ratio (%) of Barbados in 1981 to that in 1990?
Make the answer very short. 0.86. What is the ratio of the Gross enrolment ratio (%) of Nepal in 1981 to that in 1990?
Give a very brief answer. 0.68. What is the ratio of the Gross enrolment ratio (%) in Sweden in 1981 to that in 1990?
Provide a short and direct response. 1. What is the ratio of the Gross enrolment ratio (%) in Zambia in 1981 to that in 1990?
Give a very brief answer. 0.7. What is the ratio of the Gross enrolment ratio (%) in Barbados in 1981 to that in 2000?
Your response must be concise. 0.36. What is the ratio of the Gross enrolment ratio (%) of Nepal in 1981 to that in 2000?
Offer a terse response. 0.83. What is the ratio of the Gross enrolment ratio (%) of Sweden in 1981 to that in 2000?
Offer a terse response. 0.46. What is the ratio of the Gross enrolment ratio (%) of Zambia in 1981 to that in 2000?
Offer a terse response. 0.6. What is the ratio of the Gross enrolment ratio (%) of Barbados in 1982 to that in 1984?
Offer a very short reply. 0.94. What is the ratio of the Gross enrolment ratio (%) of Nepal in 1982 to that in 1984?
Make the answer very short. 0.98. What is the ratio of the Gross enrolment ratio (%) in Sweden in 1982 to that in 1984?
Your answer should be compact. 0.97. What is the ratio of the Gross enrolment ratio (%) of Zambia in 1982 to that in 1984?
Make the answer very short. 1. What is the ratio of the Gross enrolment ratio (%) of Barbados in 1982 to that in 1989?
Your response must be concise. 1.05. What is the ratio of the Gross enrolment ratio (%) in Nepal in 1982 to that in 1989?
Provide a succinct answer. 0.6. What is the ratio of the Gross enrolment ratio (%) of Sweden in 1982 to that in 1989?
Make the answer very short. 1.04. What is the ratio of the Gross enrolment ratio (%) in Zambia in 1982 to that in 1989?
Your answer should be very brief. 0.74. What is the ratio of the Gross enrolment ratio (%) in Barbados in 1982 to that in 1990?
Your answer should be compact. 1.05. What is the ratio of the Gross enrolment ratio (%) of Nepal in 1982 to that in 1990?
Offer a very short reply. 0.67. What is the ratio of the Gross enrolment ratio (%) in Zambia in 1982 to that in 1990?
Provide a succinct answer. 0.72. What is the ratio of the Gross enrolment ratio (%) of Barbados in 1982 to that in 2000?
Ensure brevity in your answer.  0.44. What is the ratio of the Gross enrolment ratio (%) of Nepal in 1982 to that in 2000?
Your response must be concise. 0.82. What is the ratio of the Gross enrolment ratio (%) of Sweden in 1982 to that in 2000?
Give a very brief answer. 0.47. What is the ratio of the Gross enrolment ratio (%) in Zambia in 1982 to that in 2000?
Ensure brevity in your answer.  0.62. What is the ratio of the Gross enrolment ratio (%) in Barbados in 1984 to that in 1989?
Give a very brief answer. 1.11. What is the ratio of the Gross enrolment ratio (%) in Nepal in 1984 to that in 1989?
Offer a terse response. 0.61. What is the ratio of the Gross enrolment ratio (%) in Sweden in 1984 to that in 1989?
Keep it short and to the point. 1.07. What is the ratio of the Gross enrolment ratio (%) in Zambia in 1984 to that in 1989?
Keep it short and to the point. 0.74. What is the ratio of the Gross enrolment ratio (%) of Barbados in 1984 to that in 1990?
Your response must be concise. 1.12. What is the ratio of the Gross enrolment ratio (%) of Nepal in 1984 to that in 1990?
Your response must be concise. 0.68. What is the ratio of the Gross enrolment ratio (%) of Sweden in 1984 to that in 1990?
Keep it short and to the point. 1.05. What is the ratio of the Gross enrolment ratio (%) of Zambia in 1984 to that in 1990?
Offer a very short reply. 0.72. What is the ratio of the Gross enrolment ratio (%) in Barbados in 1984 to that in 2000?
Offer a terse response. 0.46. What is the ratio of the Gross enrolment ratio (%) of Nepal in 1984 to that in 2000?
Ensure brevity in your answer.  0.84. What is the ratio of the Gross enrolment ratio (%) of Sweden in 1984 to that in 2000?
Ensure brevity in your answer.  0.48. What is the ratio of the Gross enrolment ratio (%) of Zambia in 1984 to that in 2000?
Offer a very short reply. 0.62. What is the ratio of the Gross enrolment ratio (%) of Barbados in 1989 to that in 1990?
Offer a terse response. 1. What is the ratio of the Gross enrolment ratio (%) of Nepal in 1989 to that in 1990?
Ensure brevity in your answer.  1.12. What is the ratio of the Gross enrolment ratio (%) of Sweden in 1989 to that in 1990?
Make the answer very short. 0.98. What is the ratio of the Gross enrolment ratio (%) of Zambia in 1989 to that in 1990?
Your answer should be very brief. 0.98. What is the ratio of the Gross enrolment ratio (%) of Barbados in 1989 to that in 2000?
Offer a very short reply. 0.42. What is the ratio of the Gross enrolment ratio (%) in Nepal in 1989 to that in 2000?
Your answer should be compact. 1.37. What is the ratio of the Gross enrolment ratio (%) of Sweden in 1989 to that in 2000?
Your answer should be compact. 0.45. What is the ratio of the Gross enrolment ratio (%) of Zambia in 1989 to that in 2000?
Make the answer very short. 0.84. What is the ratio of the Gross enrolment ratio (%) in Barbados in 1990 to that in 2000?
Give a very brief answer. 0.41. What is the ratio of the Gross enrolment ratio (%) in Nepal in 1990 to that in 2000?
Your answer should be very brief. 1.23. What is the ratio of the Gross enrolment ratio (%) of Sweden in 1990 to that in 2000?
Provide a succinct answer. 0.46. What is the ratio of the Gross enrolment ratio (%) in Zambia in 1990 to that in 2000?
Your answer should be compact. 0.86. What is the difference between the highest and the second highest Gross enrolment ratio (%) of Barbados?
Ensure brevity in your answer.  21.83. What is the difference between the highest and the second highest Gross enrolment ratio (%) of Nepal?
Provide a succinct answer. 0.63. What is the difference between the highest and the second highest Gross enrolment ratio (%) of Sweden?
Your response must be concise. 34.82. What is the difference between the highest and the second highest Gross enrolment ratio (%) of Zambia?
Keep it short and to the point. 0.34. What is the difference between the highest and the lowest Gross enrolment ratio (%) in Barbados?
Make the answer very short. 35.09. What is the difference between the highest and the lowest Gross enrolment ratio (%) of Nepal?
Provide a succinct answer. 4.14. What is the difference between the highest and the lowest Gross enrolment ratio (%) of Sweden?
Provide a short and direct response. 44.42. What is the difference between the highest and the lowest Gross enrolment ratio (%) in Zambia?
Your answer should be compact. 1.24. 